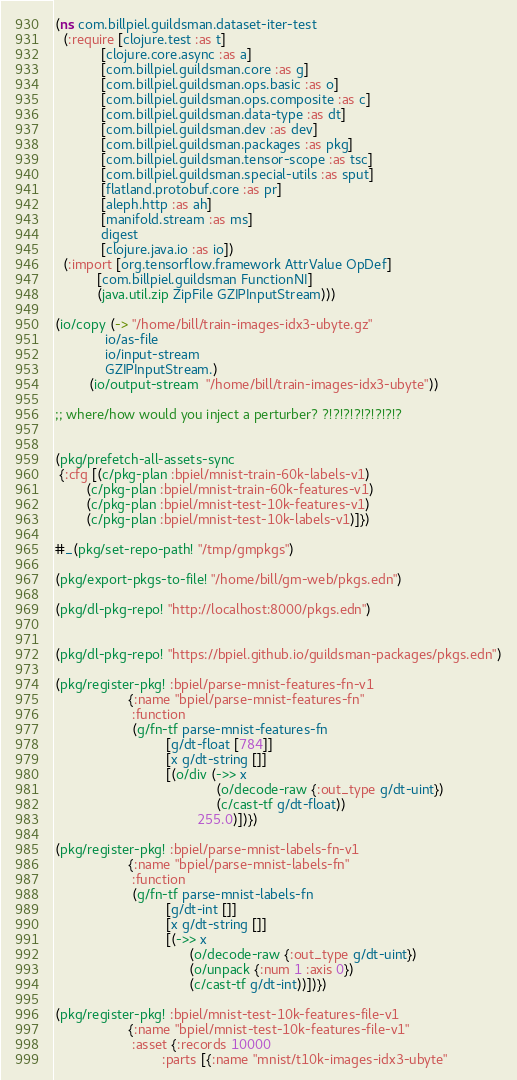Convert code to text. <code><loc_0><loc_0><loc_500><loc_500><_Clojure_>(ns com.billpiel.guildsman.dataset-iter-test
  (:require [clojure.test :as t]
            [clojure.core.async :as a]
            [com.billpiel.guildsman.core :as g]
            [com.billpiel.guildsman.ops.basic :as o]
            [com.billpiel.guildsman.ops.composite :as c]
            [com.billpiel.guildsman.data-type :as dt]
            [com.billpiel.guildsman.dev :as dev]
            [com.billpiel.guildsman.packages :as pkg]
            [com.billpiel.guildsman.tensor-scope :as tsc]
            [com.billpiel.guildsman.special-utils :as sput]
            [flatland.protobuf.core :as pr]
            [aleph.http :as ah]
            [manifold.stream :as ms]
            digest
            [clojure.java.io :as io])
  (:import [org.tensorflow.framework AttrValue OpDef]
           [com.billpiel.guildsman FunctionNI]
           (java.util.zip ZipFile GZIPInputStream)))

(io/copy (-> "/home/bill/train-images-idx3-ubyte.gz"
             io/as-file
             io/input-stream
             GZIPInputStream.)
         (io/output-stream  "/home/bill/train-images-idx3-ubyte"))

;; where/how would you inject a perturber? ?!?!?!?!?!?!?!?


(pkg/prefetch-all-assets-sync
 {:cfg [(c/pkg-plan :bpiel/mnist-train-60k-labels-v1)
        (c/pkg-plan :bpiel/mnist-train-60k-features-v1)
        (c/pkg-plan :bpiel/mnist-test-10k-features-v1)
        (c/pkg-plan :bpiel/mnist-test-10k-labels-v1)]})

#_(pkg/set-repo-path! "/tmp/gmpkgs")

(pkg/export-pkgs-to-file! "/home/bill/gm-web/pkgs.edn")

(pkg/dl-pkg-repo! "http://localhost:8000/pkgs.edn")


(pkg/dl-pkg-repo! "https://bpiel.github.io/guildsman-packages/pkgs.edn")

(pkg/register-pkg! :bpiel/parse-mnist-features-fn-v1
                   {:name "bpiel/parse-mnist-features-fn"
                    :function
                    (g/fn-tf parse-mnist-features-fn
                             [g/dt-float [784]]
                             [x g/dt-string []]
                             [(o/div (->> x
                                          (o/decode-raw {:out_type g/dt-uint})
                                          (c/cast-tf g/dt-float))
                                     255.0)])})

(pkg/register-pkg! :bpiel/parse-mnist-labels-fn-v1
                   {:name "bpiel/parse-mnist-labels-fn"
                    :function
                    (g/fn-tf parse-mnist-labels-fn
                             [g/dt-int []]
                             [x g/dt-string []]
                             [(->> x
                                   (o/decode-raw {:out_type g/dt-uint})
                                   (o/unpack {:num 1 :axis 0})
                                   (c/cast-tf g/dt-int))])})

(pkg/register-pkg! :bpiel/mnist-test-10k-features-file-v1
                   {:name "bpiel/mnist-test-10k-features-file-v1"
                    :asset {:records 10000        
                            :parts [{:name "mnist/t10k-images-idx3-ubyte"</code> 